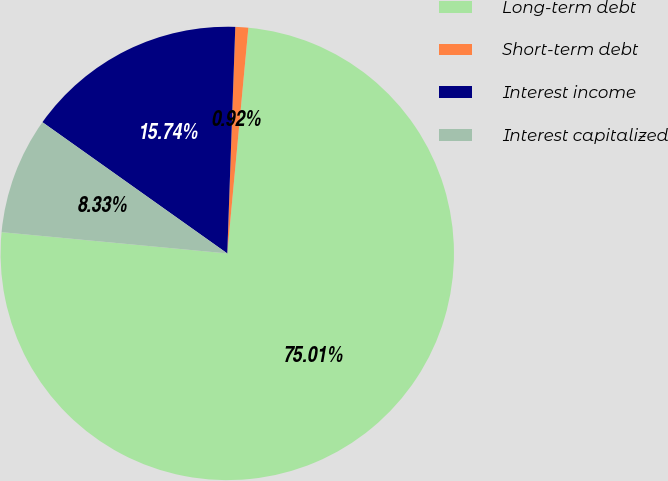Convert chart to OTSL. <chart><loc_0><loc_0><loc_500><loc_500><pie_chart><fcel>Long-term debt<fcel>Short-term debt<fcel>Interest income<fcel>Interest capitalized<nl><fcel>75.02%<fcel>0.92%<fcel>15.74%<fcel>8.33%<nl></chart> 